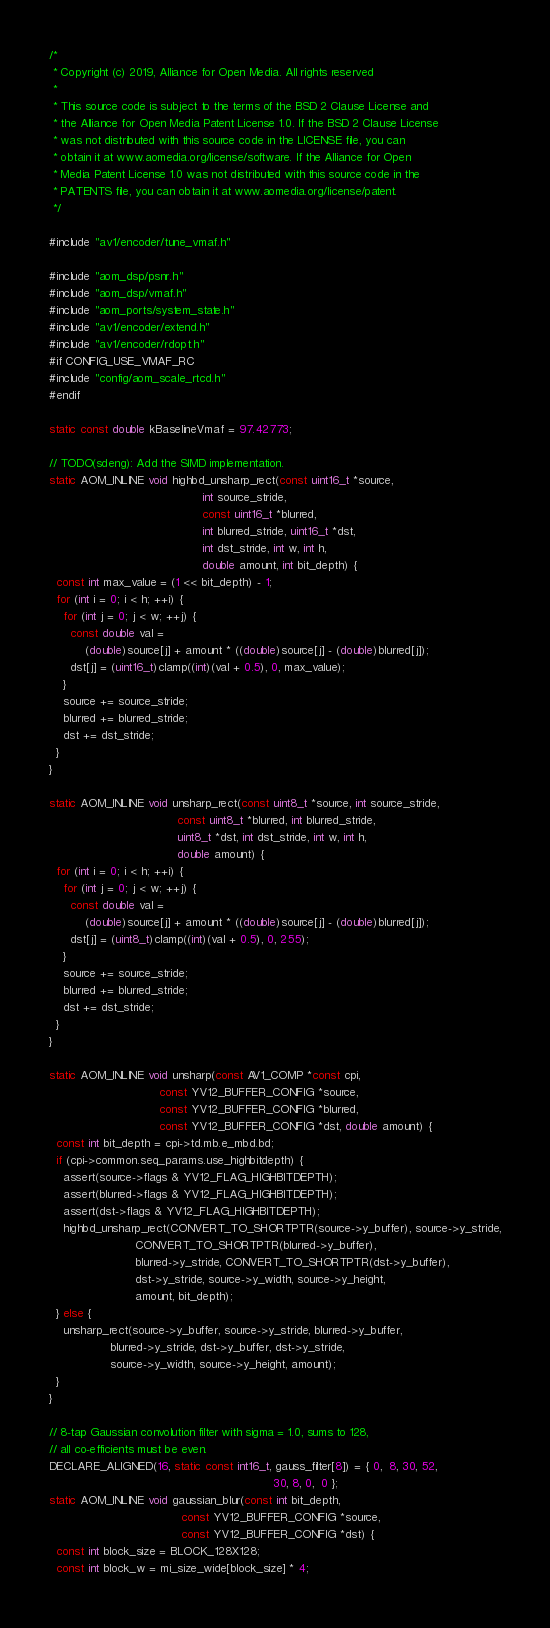Convert code to text. <code><loc_0><loc_0><loc_500><loc_500><_C_>/*
 * Copyright (c) 2019, Alliance for Open Media. All rights reserved
 *
 * This source code is subject to the terms of the BSD 2 Clause License and
 * the Alliance for Open Media Patent License 1.0. If the BSD 2 Clause License
 * was not distributed with this source code in the LICENSE file, you can
 * obtain it at www.aomedia.org/license/software. If the Alliance for Open
 * Media Patent License 1.0 was not distributed with this source code in the
 * PATENTS file, you can obtain it at www.aomedia.org/license/patent.
 */

#include "av1/encoder/tune_vmaf.h"

#include "aom_dsp/psnr.h"
#include "aom_dsp/vmaf.h"
#include "aom_ports/system_state.h"
#include "av1/encoder/extend.h"
#include "av1/encoder/rdopt.h"
#if CONFIG_USE_VMAF_RC
#include "config/aom_scale_rtcd.h"
#endif

static const double kBaselineVmaf = 97.42773;

// TODO(sdeng): Add the SIMD implementation.
static AOM_INLINE void highbd_unsharp_rect(const uint16_t *source,
                                           int source_stride,
                                           const uint16_t *blurred,
                                           int blurred_stride, uint16_t *dst,
                                           int dst_stride, int w, int h,
                                           double amount, int bit_depth) {
  const int max_value = (1 << bit_depth) - 1;
  for (int i = 0; i < h; ++i) {
    for (int j = 0; j < w; ++j) {
      const double val =
          (double)source[j] + amount * ((double)source[j] - (double)blurred[j]);
      dst[j] = (uint16_t)clamp((int)(val + 0.5), 0, max_value);
    }
    source += source_stride;
    blurred += blurred_stride;
    dst += dst_stride;
  }
}

static AOM_INLINE void unsharp_rect(const uint8_t *source, int source_stride,
                                    const uint8_t *blurred, int blurred_stride,
                                    uint8_t *dst, int dst_stride, int w, int h,
                                    double amount) {
  for (int i = 0; i < h; ++i) {
    for (int j = 0; j < w; ++j) {
      const double val =
          (double)source[j] + amount * ((double)source[j] - (double)blurred[j]);
      dst[j] = (uint8_t)clamp((int)(val + 0.5), 0, 255);
    }
    source += source_stride;
    blurred += blurred_stride;
    dst += dst_stride;
  }
}

static AOM_INLINE void unsharp(const AV1_COMP *const cpi,
                               const YV12_BUFFER_CONFIG *source,
                               const YV12_BUFFER_CONFIG *blurred,
                               const YV12_BUFFER_CONFIG *dst, double amount) {
  const int bit_depth = cpi->td.mb.e_mbd.bd;
  if (cpi->common.seq_params.use_highbitdepth) {
    assert(source->flags & YV12_FLAG_HIGHBITDEPTH);
    assert(blurred->flags & YV12_FLAG_HIGHBITDEPTH);
    assert(dst->flags & YV12_FLAG_HIGHBITDEPTH);
    highbd_unsharp_rect(CONVERT_TO_SHORTPTR(source->y_buffer), source->y_stride,
                        CONVERT_TO_SHORTPTR(blurred->y_buffer),
                        blurred->y_stride, CONVERT_TO_SHORTPTR(dst->y_buffer),
                        dst->y_stride, source->y_width, source->y_height,
                        amount, bit_depth);
  } else {
    unsharp_rect(source->y_buffer, source->y_stride, blurred->y_buffer,
                 blurred->y_stride, dst->y_buffer, dst->y_stride,
                 source->y_width, source->y_height, amount);
  }
}

// 8-tap Gaussian convolution filter with sigma = 1.0, sums to 128,
// all co-efficients must be even.
DECLARE_ALIGNED(16, static const int16_t, gauss_filter[8]) = { 0,  8, 30, 52,
                                                               30, 8, 0,  0 };
static AOM_INLINE void gaussian_blur(const int bit_depth,
                                     const YV12_BUFFER_CONFIG *source,
                                     const YV12_BUFFER_CONFIG *dst) {
  const int block_size = BLOCK_128X128;
  const int block_w = mi_size_wide[block_size] * 4;</code> 